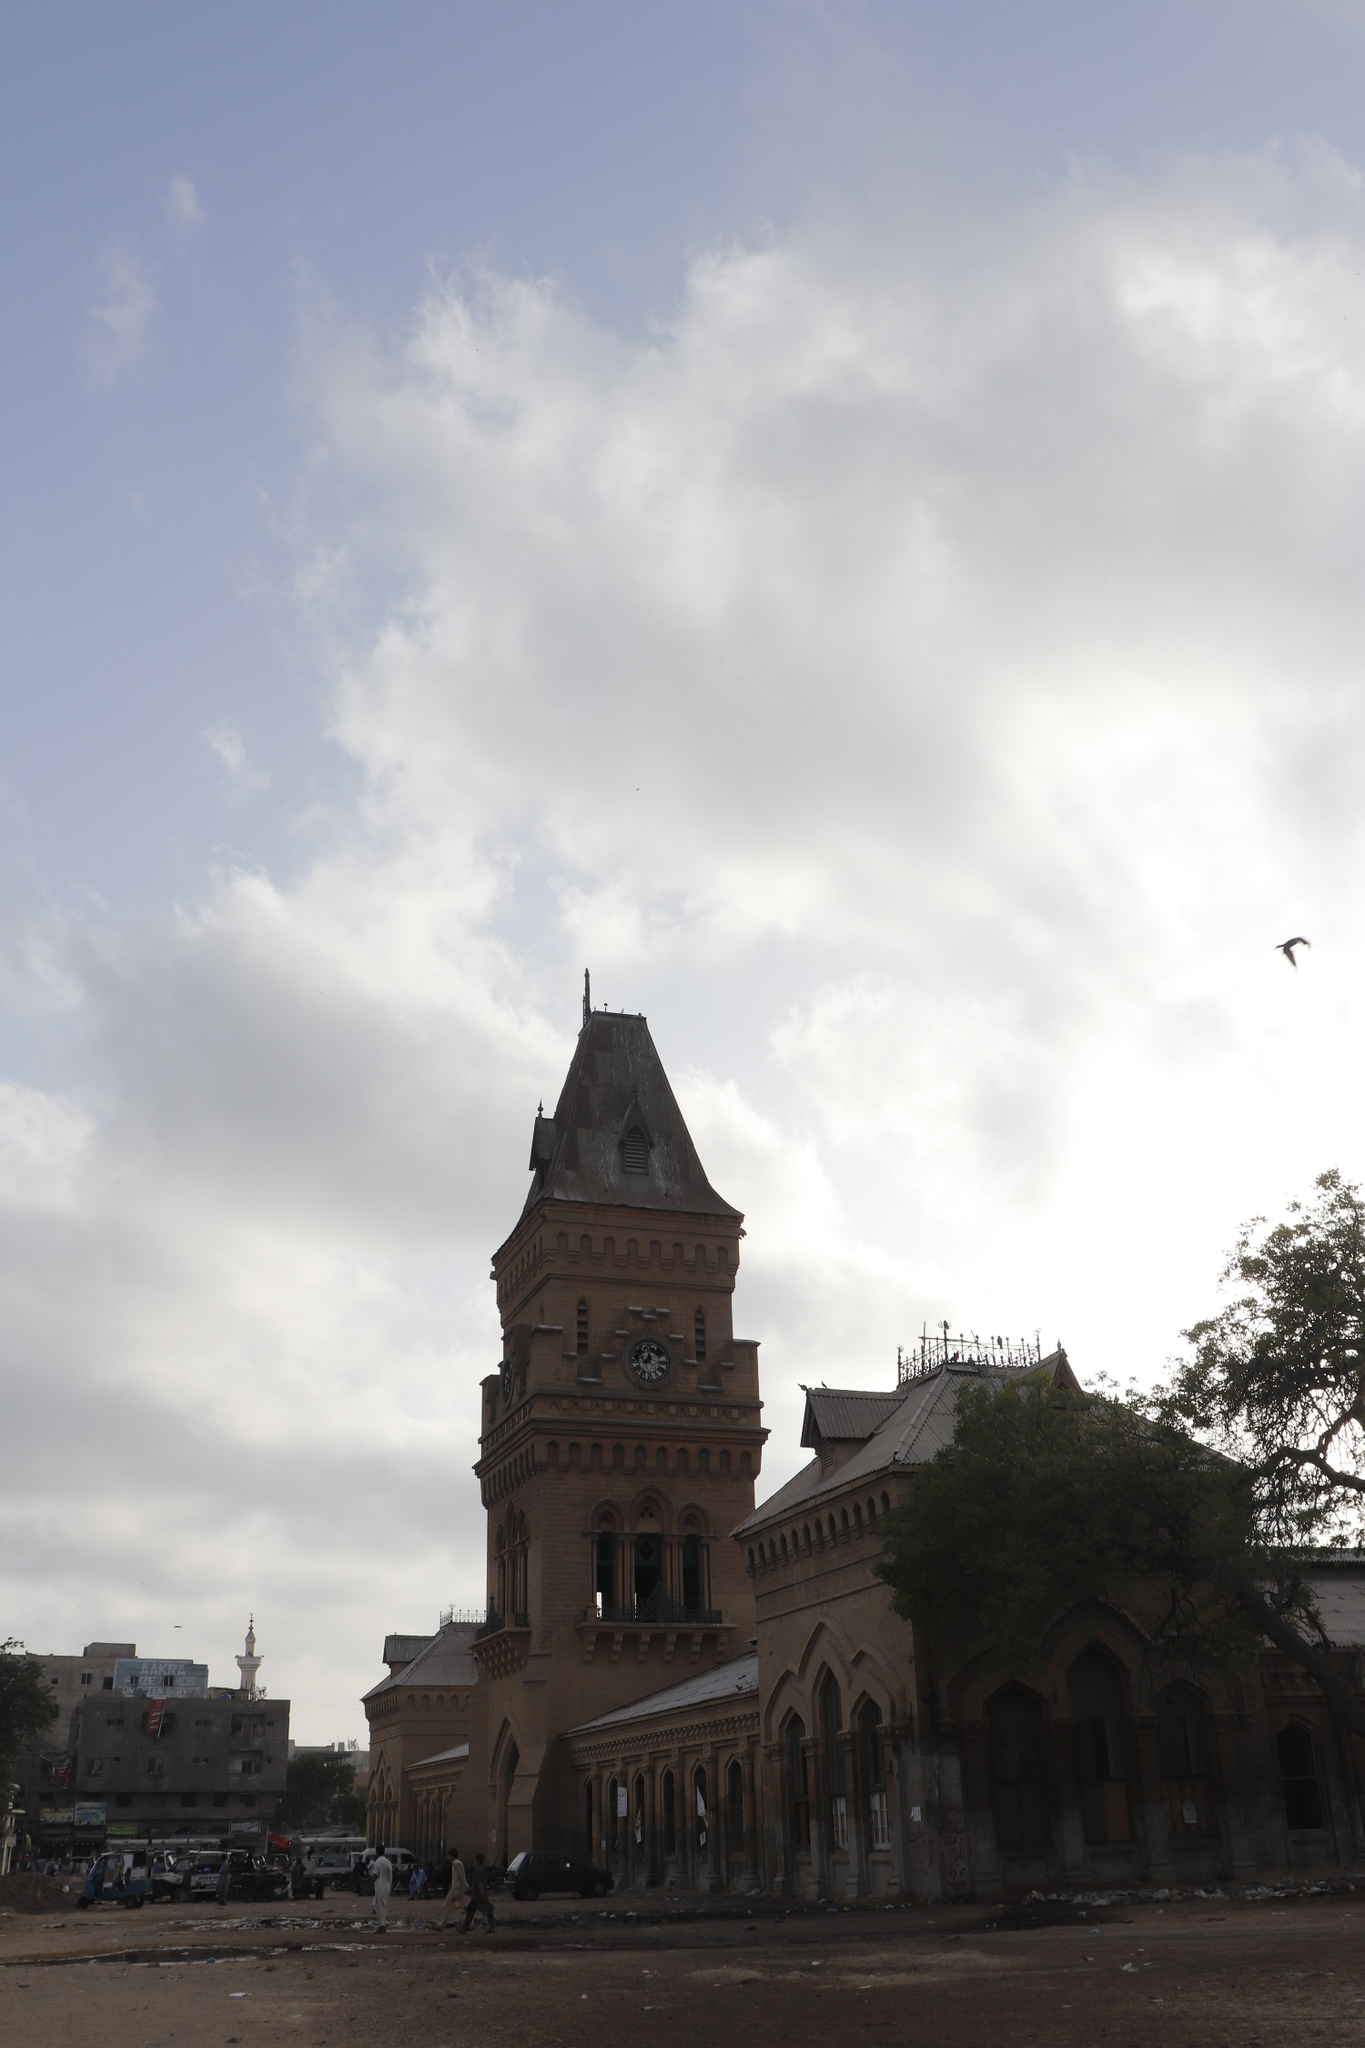Describe the Empress Market if it were portrayed in a science fiction setting. In a futuristic reimagining, the Empress Market stands as a towering beacon of neo-Gothic architecture amidst a city of sleek, towering skyscrapers. Its facade, made of shimmering metals and advanced polymers, reflects a fusion between traditional design and futuristic materials. The clock tower, now equipped with advanced holographic displays, tells the time in various galactic languages. Drones hover around, ensuring security and providing real-time updates on market activities. The stalls, once brimming with spices and produce, now showcase exotic intergalactic goods – luminescent fruits, synthetic spices, and gadgets from distant planets. The sky above, filled with flying vehicles and distant spacecraft, adds a thrilling depth to the scene, enhancing the narrative of a marketplace that has transcended time and embraced the cosmos. 